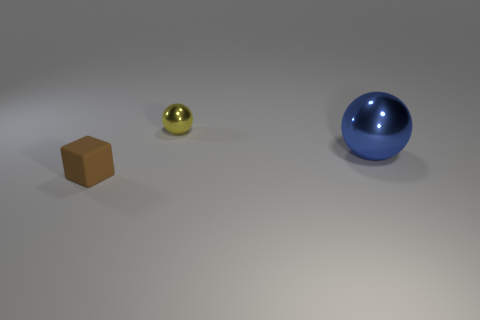There is a large blue metal thing; are there any rubber cubes in front of it?
Give a very brief answer. Yes. The object that is to the right of the brown rubber cube and on the left side of the large blue sphere has what shape?
Provide a short and direct response. Sphere. Are there any tiny cyan metallic things of the same shape as the brown thing?
Your answer should be compact. No. There is a object that is left of the small yellow shiny sphere; is it the same size as the ball behind the large blue metallic thing?
Offer a terse response. Yes. Are there more big blue metallic balls than tiny red shiny balls?
Provide a succinct answer. Yes. What number of big spheres have the same material as the tiny sphere?
Provide a short and direct response. 1. Is the big shiny object the same shape as the tiny shiny thing?
Offer a very short reply. Yes. How big is the object that is behind the sphere that is in front of the tiny object behind the rubber thing?
Provide a succinct answer. Small. There is a tiny object right of the matte block; are there any small brown objects right of it?
Your answer should be compact. No. How many small metal objects are in front of the metallic ball to the right of the tiny object that is on the right side of the tiny matte cube?
Offer a terse response. 0. 